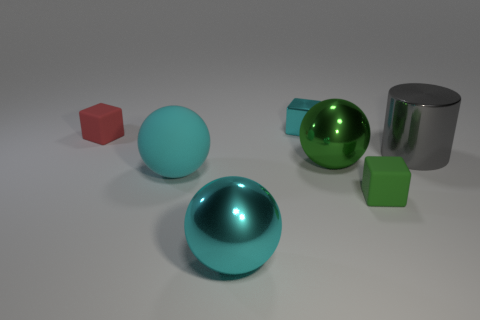Subtract all tiny cyan blocks. How many blocks are left? 2 Subtract all purple blocks. How many cyan spheres are left? 2 Add 2 large brown matte cylinders. How many objects exist? 9 Subtract 1 gray cylinders. How many objects are left? 6 Subtract all cylinders. How many objects are left? 6 Subtract all purple balls. Subtract all brown cubes. How many balls are left? 3 Subtract all small metallic blocks. Subtract all green rubber blocks. How many objects are left? 5 Add 4 big gray objects. How many big gray objects are left? 5 Add 2 tiny brown shiny blocks. How many tiny brown shiny blocks exist? 2 